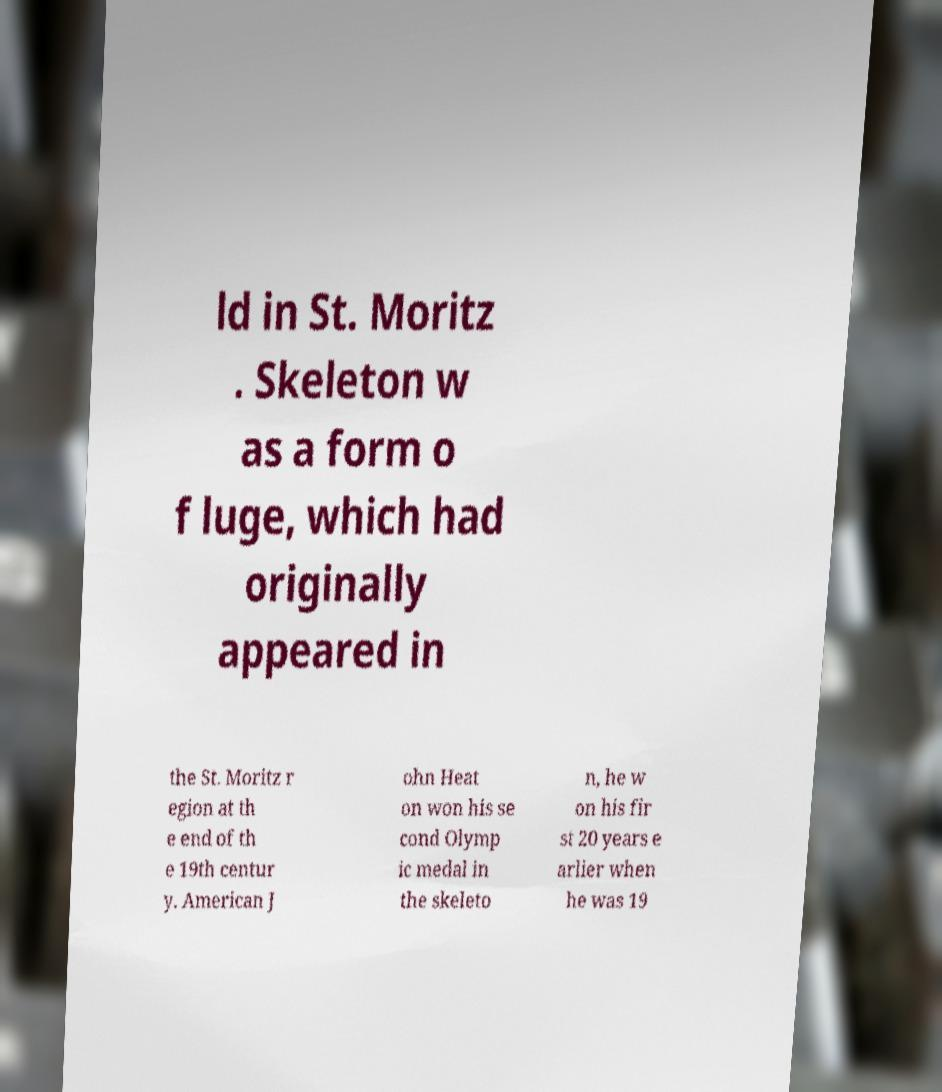Can you accurately transcribe the text from the provided image for me? ld in St. Moritz . Skeleton w as a form o f luge, which had originally appeared in the St. Moritz r egion at th e end of th e 19th centur y. American J ohn Heat on won his se cond Olymp ic medal in the skeleto n, he w on his fir st 20 years e arlier when he was 19 